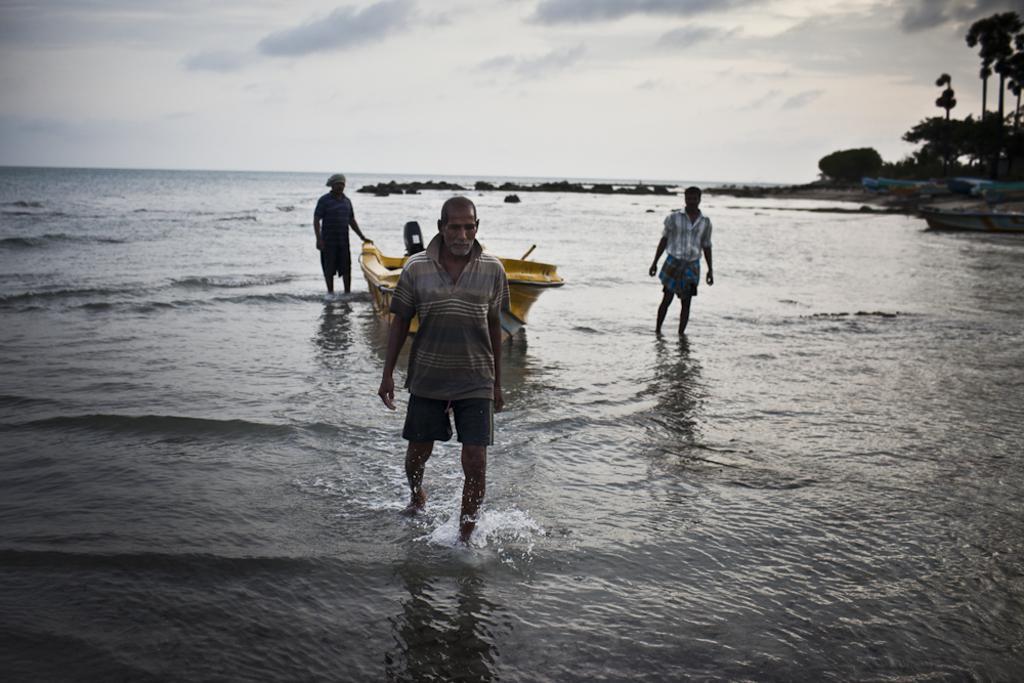Can you describe this image briefly? In this image I can see three persons walking in the water. Background I can see the boat in yellow color, few stones, trees and the sky is in white color. 